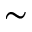Convert formula to latex. <formula><loc_0><loc_0><loc_500><loc_500>\sim</formula> 